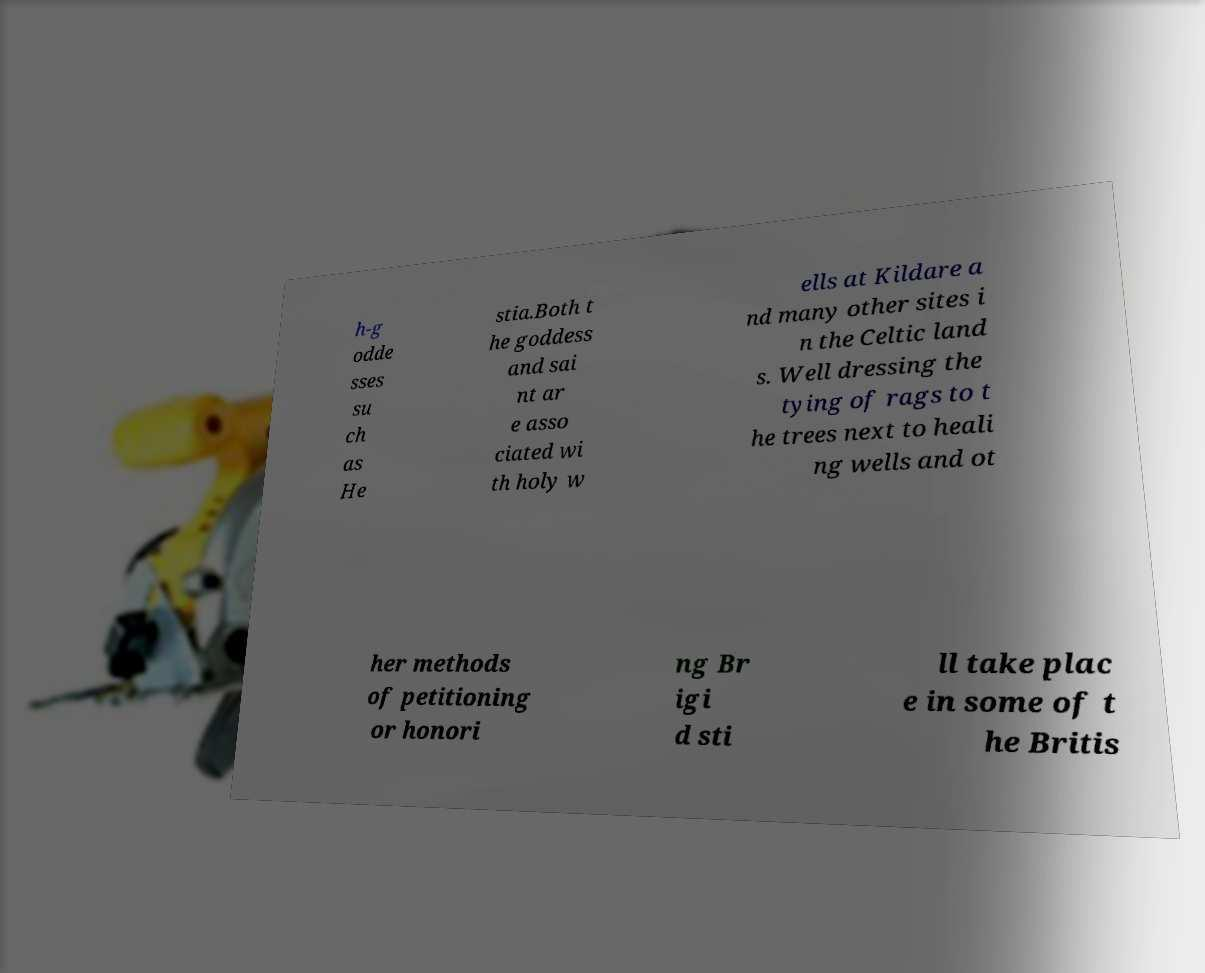There's text embedded in this image that I need extracted. Can you transcribe it verbatim? h-g odde sses su ch as He stia.Both t he goddess and sai nt ar e asso ciated wi th holy w ells at Kildare a nd many other sites i n the Celtic land s. Well dressing the tying of rags to t he trees next to heali ng wells and ot her methods of petitioning or honori ng Br igi d sti ll take plac e in some of t he Britis 